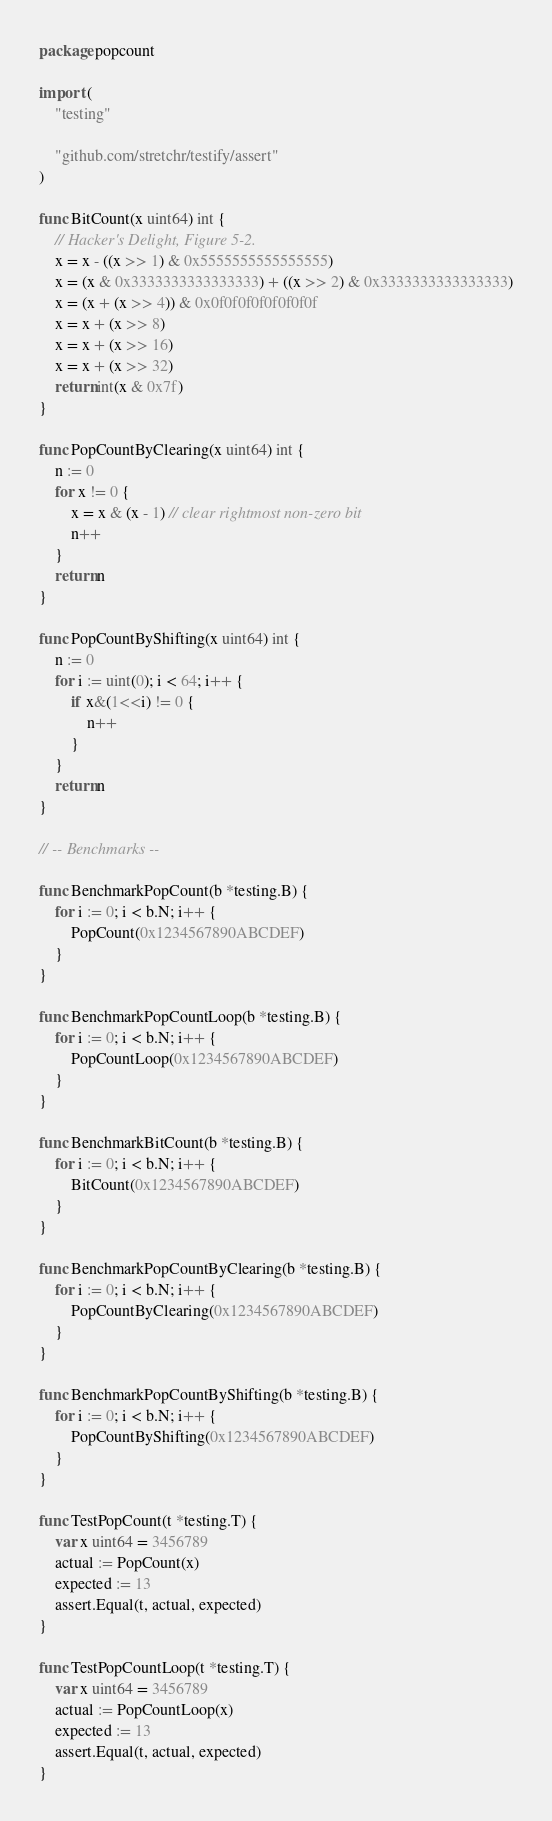Convert code to text. <code><loc_0><loc_0><loc_500><loc_500><_Go_>package popcount

import (
	"testing"

	"github.com/stretchr/testify/assert"
)

func BitCount(x uint64) int {
	// Hacker's Delight, Figure 5-2.
	x = x - ((x >> 1) & 0x5555555555555555)
	x = (x & 0x3333333333333333) + ((x >> 2) & 0x3333333333333333)
	x = (x + (x >> 4)) & 0x0f0f0f0f0f0f0f0f
	x = x + (x >> 8)
	x = x + (x >> 16)
	x = x + (x >> 32)
	return int(x & 0x7f)
}

func PopCountByClearing(x uint64) int {
	n := 0
	for x != 0 {
		x = x & (x - 1) // clear rightmost non-zero bit
		n++
	}
	return n
}

func PopCountByShifting(x uint64) int {
	n := 0
	for i := uint(0); i < 64; i++ {
		if x&(1<<i) != 0 {
			n++
		}
	}
	return n
}

// -- Benchmarks --

func BenchmarkPopCount(b *testing.B) {
	for i := 0; i < b.N; i++ {
		PopCount(0x1234567890ABCDEF)
	}
}

func BenchmarkPopCountLoop(b *testing.B) {
	for i := 0; i < b.N; i++ {
		PopCountLoop(0x1234567890ABCDEF)
	}
}

func BenchmarkBitCount(b *testing.B) {
	for i := 0; i < b.N; i++ {
		BitCount(0x1234567890ABCDEF)
	}
}

func BenchmarkPopCountByClearing(b *testing.B) {
	for i := 0; i < b.N; i++ {
		PopCountByClearing(0x1234567890ABCDEF)
	}
}

func BenchmarkPopCountByShifting(b *testing.B) {
	for i := 0; i < b.N; i++ {
		PopCountByShifting(0x1234567890ABCDEF)
	}
}

func TestPopCount(t *testing.T) {
	var x uint64 = 3456789
	actual := PopCount(x)
	expected := 13
	assert.Equal(t, actual, expected)
}

func TestPopCountLoop(t *testing.T) {
	var x uint64 = 3456789
	actual := PopCountLoop(x)
	expected := 13
	assert.Equal(t, actual, expected)
}
</code> 